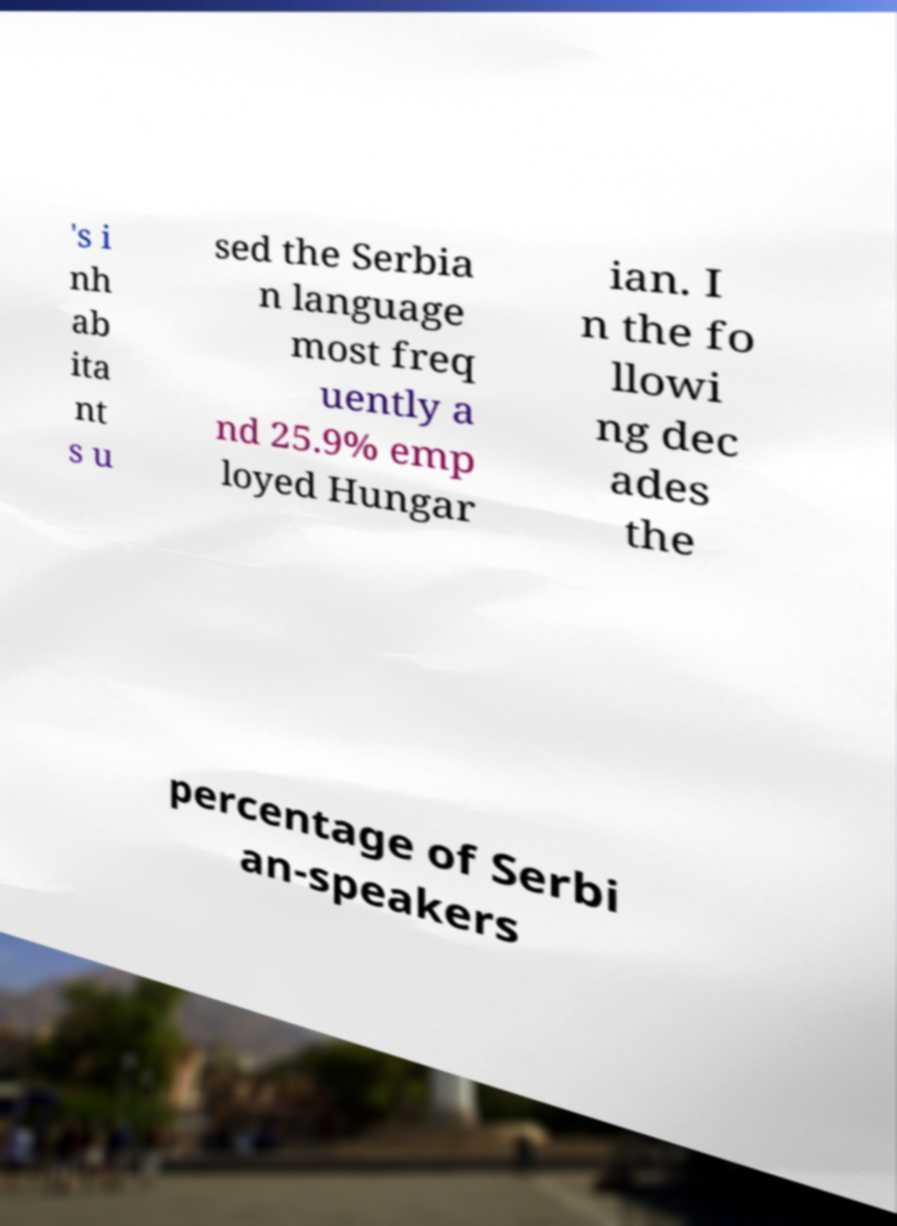There's text embedded in this image that I need extracted. Can you transcribe it verbatim? 's i nh ab ita nt s u sed the Serbia n language most freq uently a nd 25.9% emp loyed Hungar ian. I n the fo llowi ng dec ades the percentage of Serbi an-speakers 